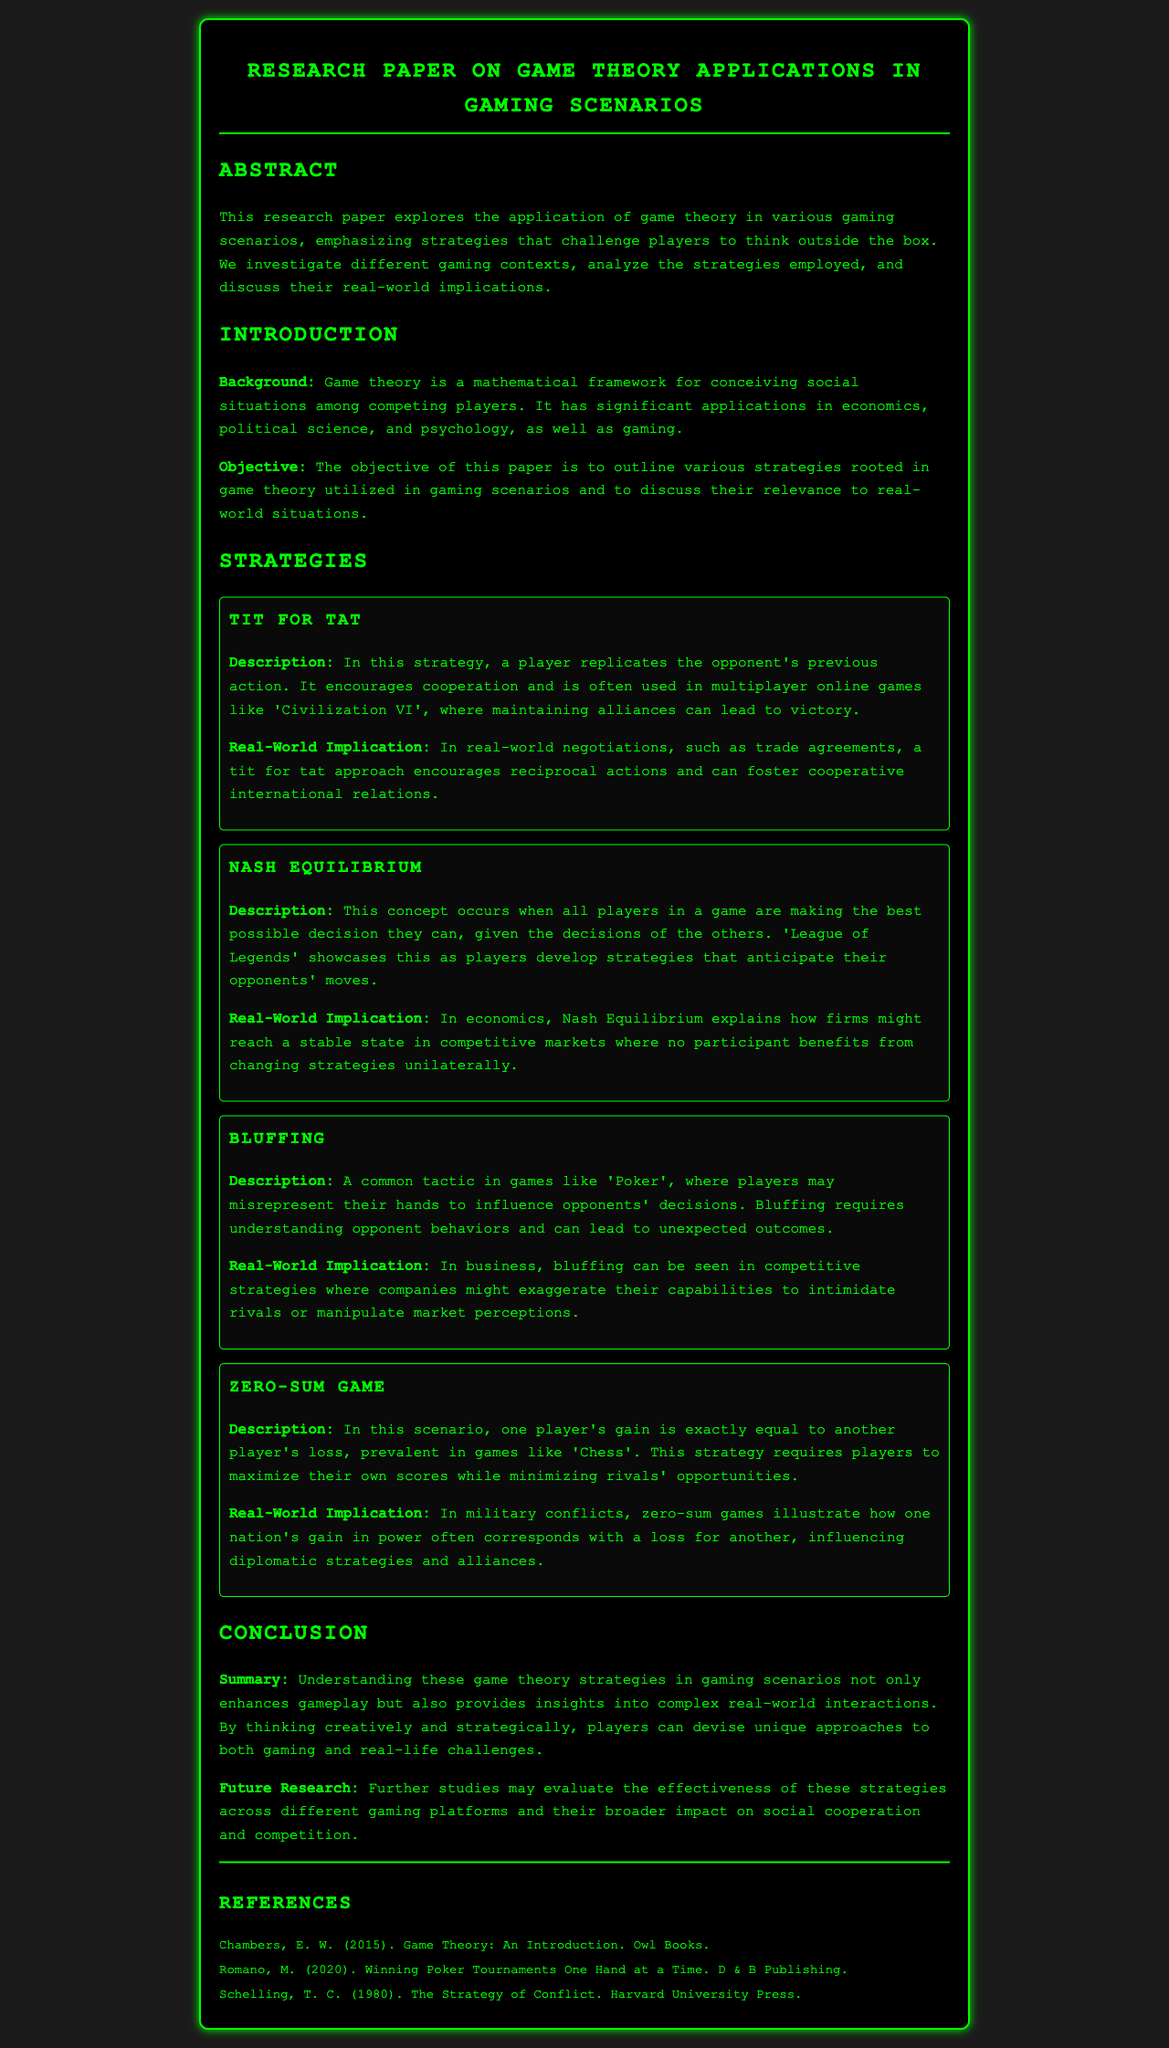What is the title of the research paper? The title is found in the header section of the document.
Answer: Research Paper on Game Theory Applications in Gaming Scenarios What strategy is described as encouraging cooperation by replicating an opponent's action? This information is in the Strategies section.
Answer: Tit for Tat In which game is the Nash Equilibrium strategy prominently showcased? The game referenced is indicated within the context of the Nash Equilibrium description.
Answer: League of Legends What year was "Game Theory: An Introduction" published? This information can be found in the References section of the document.
Answer: 2015 What is a key characteristic of a Zero-Sum Game? The document describes this concept within the Zero-Sum Game strategy.
Answer: One player's gain is exactly equal to another player's loss What do players need to understand in order to effectively use the Bluffing strategy? This requires piecing together the details from the description of Bluffing.
Answer: Opponent behaviors What is the main objective of the research paper? The objective is outlined in the Introduction section.
Answer: To outline various strategies rooted in game theory utilized in gaming scenarios What concept explains how firms might reach a stable state in competitive markets? This is derived from the discussion around Nash Equilibrium.
Answer: Nash Equilibrium What does the conclusion suggest for future research? This implies looking for new insights based on provided information in the Conclusion.
Answer: Evaluate the effectiveness of these strategies across different gaming platforms 